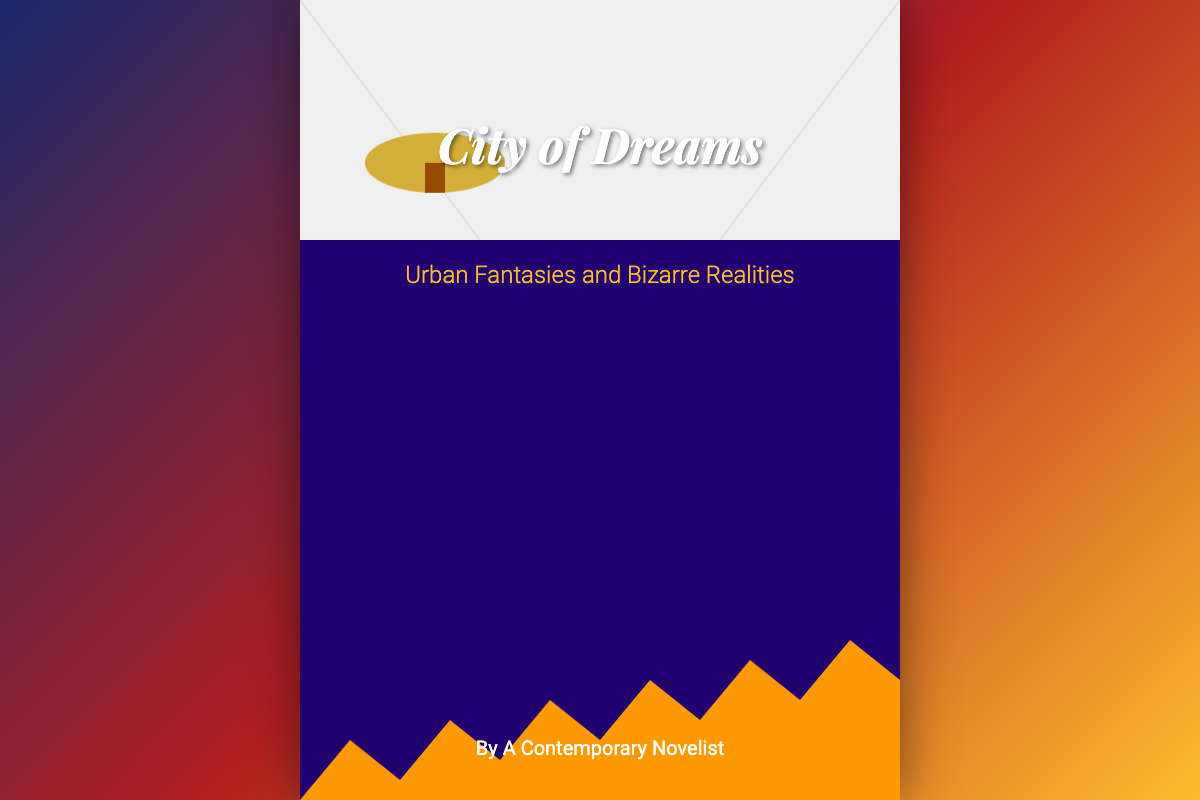What is the title of the book? The title is prominently displayed at the top of the cover in large text.
Answer: City of Dreams What is the subtitle of the book? The subtitle is located beneath the title and describes the content of the book.
Answer: Urban Fantasies and Bizarre Realities Who is the author of the book? The author's name is included at the bottom of the cover.
Answer: A Contemporary Novelist What color primarily sets the background gradient? The background gradient moves from dark blue to red to gold.
Answer: Blue What is featured at the top of the cover? The top of the cover showcases an illustration of an airship floating.
Answer: Airship What is the main visual theme of the cover? The cover's imagery emphasizes a mix of urban architecture and fantastical elements.
Answer: Surreal cityscape How much of the cover is dedicated to the cityscape? The cityscape occupies the majority of the bottom portion of the cover.
Answer: 70% What element twists into the heavens? The streets depicted in the cover are illustrated as twisting upwards.
Answer: Streets What type of buildings are depicted in the cityscape? The buildings in this surreal city are designed to resemble literary works.
Answer: Books 